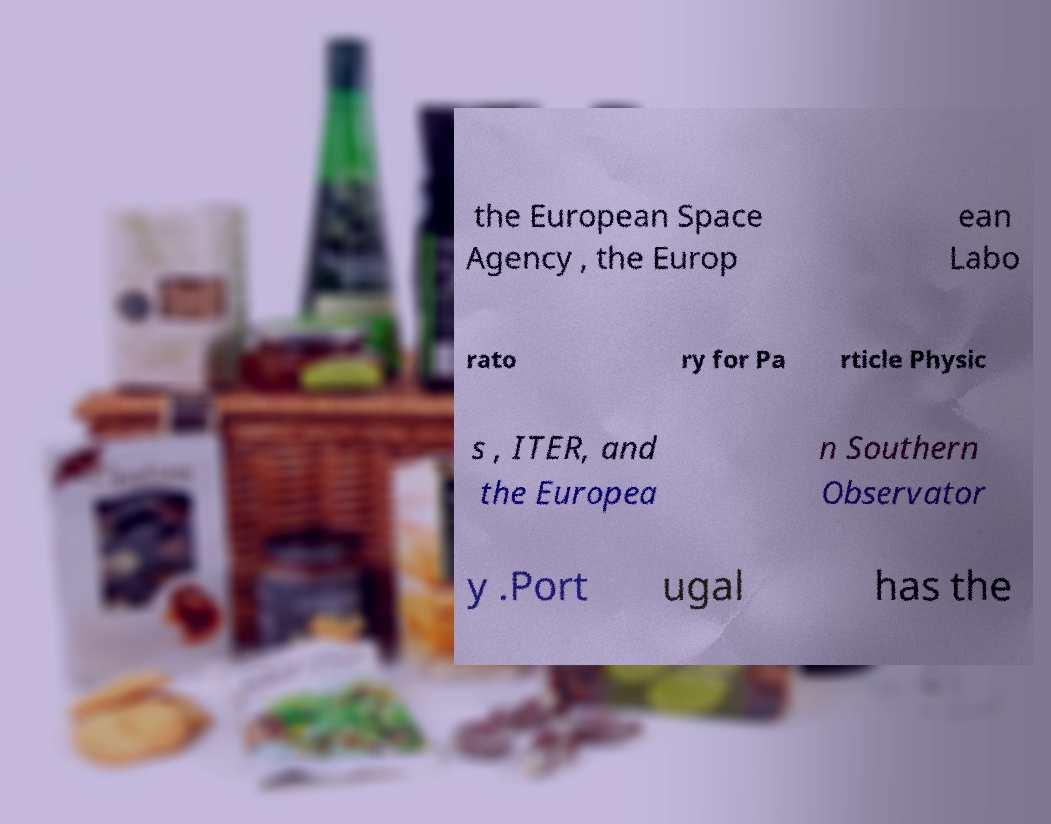Please identify and transcribe the text found in this image. the European Space Agency , the Europ ean Labo rato ry for Pa rticle Physic s , ITER, and the Europea n Southern Observator y .Port ugal has the 